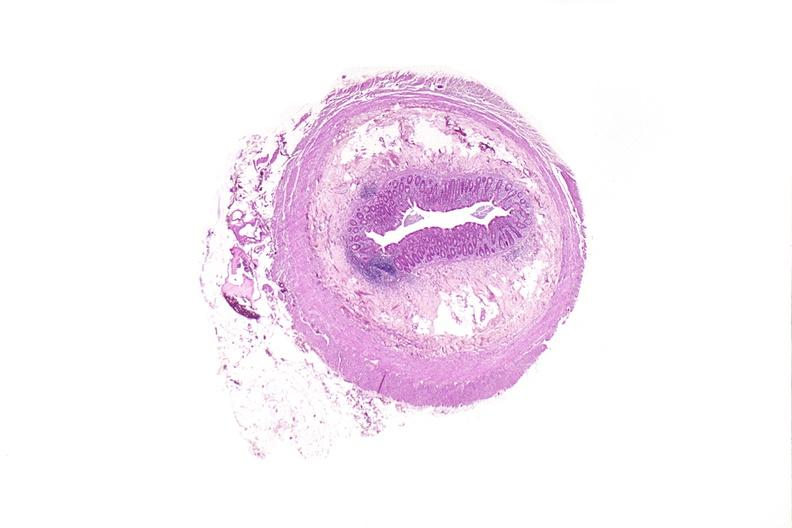s gastrointestinal present?
Answer the question using a single word or phrase. Yes 